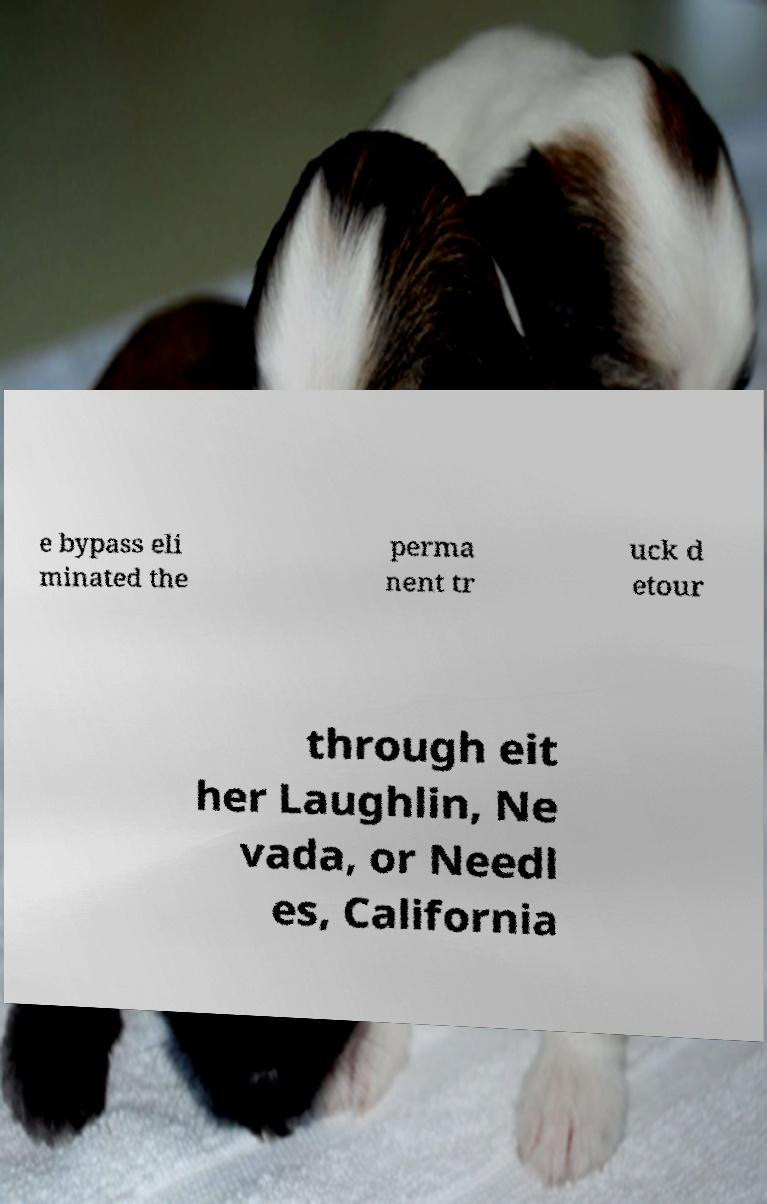Could you assist in decoding the text presented in this image and type it out clearly? e bypass eli minated the perma nent tr uck d etour through eit her Laughlin, Ne vada, or Needl es, California 